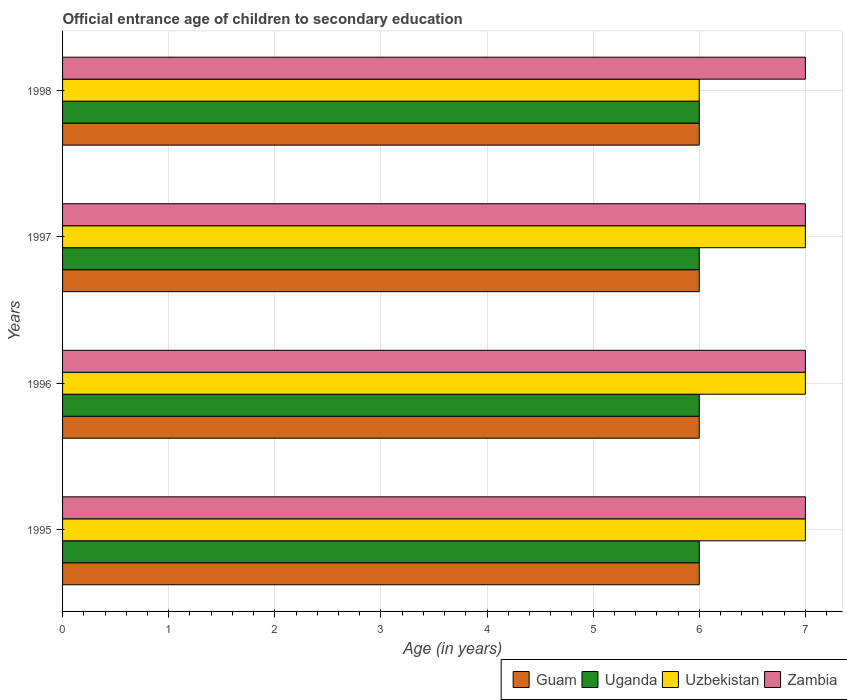How many groups of bars are there?
Give a very brief answer. 4. Are the number of bars per tick equal to the number of legend labels?
Your answer should be very brief. Yes. How many bars are there on the 1st tick from the top?
Offer a very short reply. 4. How many bars are there on the 3rd tick from the bottom?
Offer a terse response. 4. What is the label of the 2nd group of bars from the top?
Provide a succinct answer. 1997. In how many cases, is the number of bars for a given year not equal to the number of legend labels?
Offer a very short reply. 0. What is the secondary school starting age of children in Uzbekistan in 1997?
Your response must be concise. 7. Across all years, what is the maximum secondary school starting age of children in Uzbekistan?
Provide a succinct answer. 7. Across all years, what is the minimum secondary school starting age of children in Uzbekistan?
Make the answer very short. 6. In which year was the secondary school starting age of children in Guam maximum?
Make the answer very short. 1995. What is the difference between the secondary school starting age of children in Uzbekistan in 1995 and that in 1997?
Your answer should be very brief. 0. In the year 1997, what is the difference between the secondary school starting age of children in Guam and secondary school starting age of children in Uzbekistan?
Your answer should be very brief. -1. What is the ratio of the secondary school starting age of children in Uzbekistan in 1997 to that in 1998?
Your answer should be very brief. 1.17. Is the difference between the secondary school starting age of children in Guam in 1995 and 1998 greater than the difference between the secondary school starting age of children in Uzbekistan in 1995 and 1998?
Provide a succinct answer. No. What is the difference between the highest and the second highest secondary school starting age of children in Zambia?
Offer a very short reply. 0. What is the difference between the highest and the lowest secondary school starting age of children in Zambia?
Your answer should be very brief. 0. In how many years, is the secondary school starting age of children in Uzbekistan greater than the average secondary school starting age of children in Uzbekistan taken over all years?
Offer a very short reply. 3. What does the 2nd bar from the top in 1998 represents?
Offer a very short reply. Uzbekistan. What does the 2nd bar from the bottom in 1996 represents?
Offer a terse response. Uganda. How many years are there in the graph?
Offer a very short reply. 4. Are the values on the major ticks of X-axis written in scientific E-notation?
Keep it short and to the point. No. Does the graph contain grids?
Provide a succinct answer. Yes. How many legend labels are there?
Your answer should be compact. 4. What is the title of the graph?
Ensure brevity in your answer.  Official entrance age of children to secondary education. What is the label or title of the X-axis?
Your answer should be compact. Age (in years). What is the label or title of the Y-axis?
Your response must be concise. Years. What is the Age (in years) in Guam in 1995?
Make the answer very short. 6. What is the Age (in years) of Uzbekistan in 1996?
Your response must be concise. 7. What is the Age (in years) of Guam in 1998?
Offer a very short reply. 6. What is the Age (in years) in Uganda in 1998?
Offer a very short reply. 6. What is the Age (in years) of Zambia in 1998?
Your answer should be very brief. 7. Across all years, what is the maximum Age (in years) in Uganda?
Offer a terse response. 6. Across all years, what is the maximum Age (in years) of Zambia?
Make the answer very short. 7. Across all years, what is the minimum Age (in years) of Uganda?
Make the answer very short. 6. What is the total Age (in years) of Guam in the graph?
Keep it short and to the point. 24. What is the total Age (in years) in Zambia in the graph?
Give a very brief answer. 28. What is the difference between the Age (in years) of Guam in 1995 and that in 1996?
Offer a very short reply. 0. What is the difference between the Age (in years) in Uganda in 1995 and that in 1996?
Provide a succinct answer. 0. What is the difference between the Age (in years) of Uzbekistan in 1995 and that in 1996?
Ensure brevity in your answer.  0. What is the difference between the Age (in years) in Zambia in 1995 and that in 1996?
Provide a succinct answer. 0. What is the difference between the Age (in years) in Uganda in 1995 and that in 1997?
Offer a terse response. 0. What is the difference between the Age (in years) of Uzbekistan in 1995 and that in 1997?
Make the answer very short. 0. What is the difference between the Age (in years) of Zambia in 1995 and that in 1997?
Your answer should be very brief. 0. What is the difference between the Age (in years) of Guam in 1995 and that in 1998?
Provide a short and direct response. 0. What is the difference between the Age (in years) in Uganda in 1995 and that in 1998?
Offer a very short reply. 0. What is the difference between the Age (in years) of Uzbekistan in 1995 and that in 1998?
Your response must be concise. 1. What is the difference between the Age (in years) of Uganda in 1996 and that in 1997?
Your answer should be very brief. 0. What is the difference between the Age (in years) of Zambia in 1996 and that in 1997?
Your answer should be compact. 0. What is the difference between the Age (in years) of Guam in 1996 and that in 1998?
Make the answer very short. 0. What is the difference between the Age (in years) in Uganda in 1996 and that in 1998?
Ensure brevity in your answer.  0. What is the difference between the Age (in years) of Zambia in 1996 and that in 1998?
Make the answer very short. 0. What is the difference between the Age (in years) in Zambia in 1997 and that in 1998?
Provide a succinct answer. 0. What is the difference between the Age (in years) of Guam in 1995 and the Age (in years) of Uzbekistan in 1996?
Make the answer very short. -1. What is the difference between the Age (in years) of Uzbekistan in 1995 and the Age (in years) of Zambia in 1996?
Ensure brevity in your answer.  0. What is the difference between the Age (in years) in Guam in 1995 and the Age (in years) in Uzbekistan in 1997?
Your answer should be very brief. -1. What is the difference between the Age (in years) in Guam in 1995 and the Age (in years) in Zambia in 1997?
Make the answer very short. -1. What is the difference between the Age (in years) in Uzbekistan in 1995 and the Age (in years) in Zambia in 1997?
Offer a very short reply. 0. What is the difference between the Age (in years) of Guam in 1995 and the Age (in years) of Uganda in 1998?
Your response must be concise. 0. What is the difference between the Age (in years) in Guam in 1995 and the Age (in years) in Uzbekistan in 1998?
Provide a succinct answer. 0. What is the difference between the Age (in years) of Guam in 1996 and the Age (in years) of Uganda in 1997?
Give a very brief answer. 0. What is the difference between the Age (in years) of Guam in 1996 and the Age (in years) of Zambia in 1997?
Your answer should be compact. -1. What is the difference between the Age (in years) of Uganda in 1996 and the Age (in years) of Uzbekistan in 1997?
Offer a very short reply. -1. What is the difference between the Age (in years) in Uganda in 1996 and the Age (in years) in Zambia in 1997?
Provide a short and direct response. -1. What is the difference between the Age (in years) of Guam in 1996 and the Age (in years) of Uganda in 1998?
Keep it short and to the point. 0. What is the difference between the Age (in years) of Guam in 1996 and the Age (in years) of Uzbekistan in 1998?
Give a very brief answer. 0. What is the difference between the Age (in years) in Guam in 1996 and the Age (in years) in Zambia in 1998?
Your response must be concise. -1. What is the difference between the Age (in years) of Uganda in 1996 and the Age (in years) of Uzbekistan in 1998?
Provide a short and direct response. 0. What is the difference between the Age (in years) of Guam in 1997 and the Age (in years) of Uganda in 1998?
Your response must be concise. 0. What is the difference between the Age (in years) in Guam in 1997 and the Age (in years) in Zambia in 1998?
Your answer should be very brief. -1. What is the difference between the Age (in years) of Uganda in 1997 and the Age (in years) of Zambia in 1998?
Your response must be concise. -1. What is the average Age (in years) of Uganda per year?
Give a very brief answer. 6. What is the average Age (in years) of Uzbekistan per year?
Make the answer very short. 6.75. In the year 1995, what is the difference between the Age (in years) of Uganda and Age (in years) of Uzbekistan?
Offer a very short reply. -1. In the year 1996, what is the difference between the Age (in years) of Guam and Age (in years) of Uganda?
Offer a very short reply. 0. In the year 1996, what is the difference between the Age (in years) in Uganda and Age (in years) in Zambia?
Ensure brevity in your answer.  -1. In the year 1996, what is the difference between the Age (in years) of Uzbekistan and Age (in years) of Zambia?
Offer a terse response. 0. In the year 1997, what is the difference between the Age (in years) in Guam and Age (in years) in Uzbekistan?
Provide a short and direct response. -1. In the year 1997, what is the difference between the Age (in years) of Uzbekistan and Age (in years) of Zambia?
Your answer should be very brief. 0. In the year 1998, what is the difference between the Age (in years) of Guam and Age (in years) of Uganda?
Offer a very short reply. 0. What is the ratio of the Age (in years) in Guam in 1995 to that in 1997?
Keep it short and to the point. 1. What is the ratio of the Age (in years) in Zambia in 1995 to that in 1997?
Make the answer very short. 1. What is the ratio of the Age (in years) of Uzbekistan in 1995 to that in 1998?
Give a very brief answer. 1.17. What is the ratio of the Age (in years) in Zambia in 1996 to that in 1997?
Make the answer very short. 1. What is the ratio of the Age (in years) of Uzbekistan in 1996 to that in 1998?
Ensure brevity in your answer.  1.17. What is the ratio of the Age (in years) of Zambia in 1996 to that in 1998?
Your response must be concise. 1. What is the ratio of the Age (in years) of Uzbekistan in 1997 to that in 1998?
Make the answer very short. 1.17. What is the ratio of the Age (in years) of Zambia in 1997 to that in 1998?
Ensure brevity in your answer.  1. What is the difference between the highest and the second highest Age (in years) in Uzbekistan?
Provide a succinct answer. 0. What is the difference between the highest and the second highest Age (in years) in Zambia?
Provide a succinct answer. 0. What is the difference between the highest and the lowest Age (in years) in Zambia?
Provide a succinct answer. 0. 